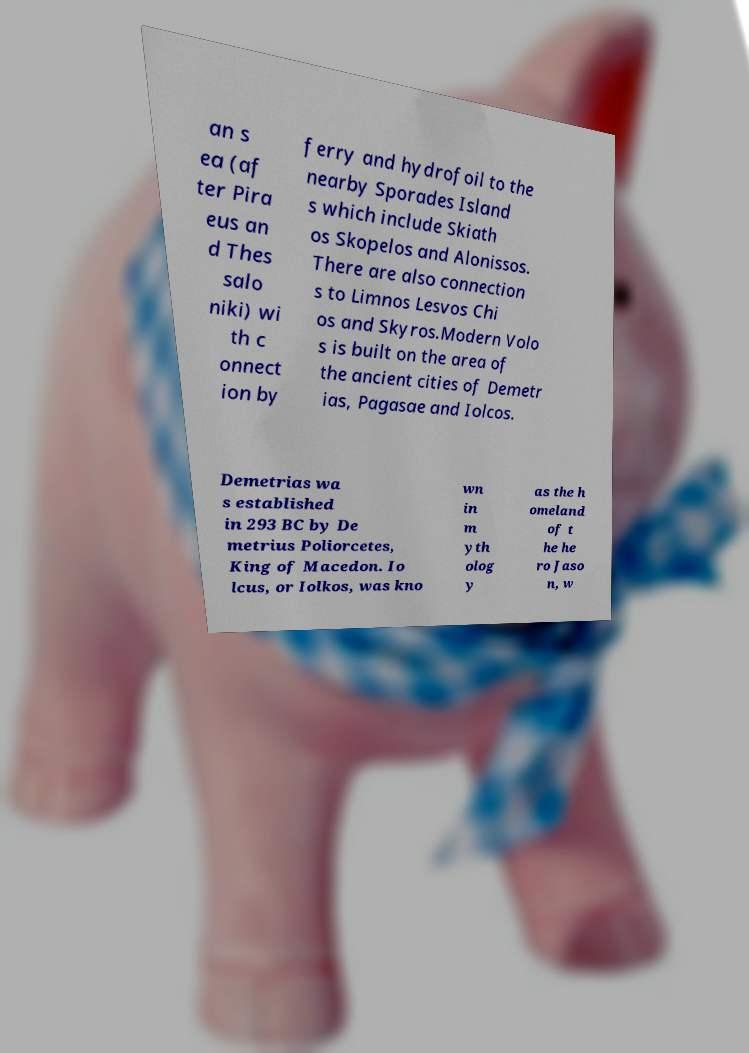For documentation purposes, I need the text within this image transcribed. Could you provide that? an s ea (af ter Pira eus an d Thes salo niki) wi th c onnect ion by ferry and hydrofoil to the nearby Sporades Island s which include Skiath os Skopelos and Alonissos. There are also connection s to Limnos Lesvos Chi os and Skyros.Modern Volo s is built on the area of the ancient cities of Demetr ias, Pagasae and Iolcos. Demetrias wa s established in 293 BC by De metrius Poliorcetes, King of Macedon. Io lcus, or Iolkos, was kno wn in m yth olog y as the h omeland of t he he ro Jaso n, w 